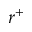Convert formula to latex. <formula><loc_0><loc_0><loc_500><loc_500>r ^ { + }</formula> 